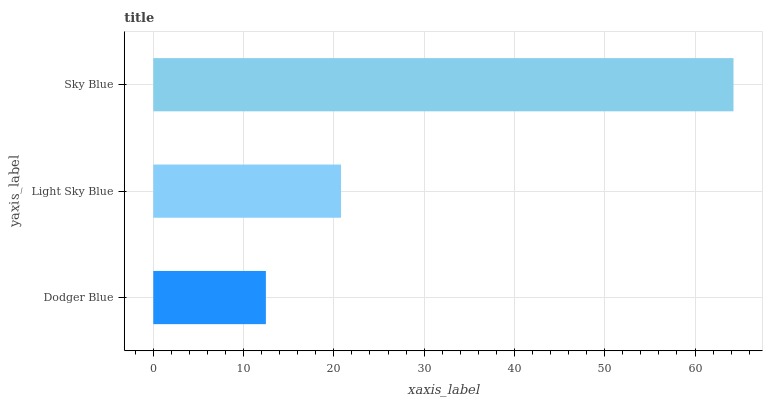Is Dodger Blue the minimum?
Answer yes or no. Yes. Is Sky Blue the maximum?
Answer yes or no. Yes. Is Light Sky Blue the minimum?
Answer yes or no. No. Is Light Sky Blue the maximum?
Answer yes or no. No. Is Light Sky Blue greater than Dodger Blue?
Answer yes or no. Yes. Is Dodger Blue less than Light Sky Blue?
Answer yes or no. Yes. Is Dodger Blue greater than Light Sky Blue?
Answer yes or no. No. Is Light Sky Blue less than Dodger Blue?
Answer yes or no. No. Is Light Sky Blue the high median?
Answer yes or no. Yes. Is Light Sky Blue the low median?
Answer yes or no. Yes. Is Dodger Blue the high median?
Answer yes or no. No. Is Dodger Blue the low median?
Answer yes or no. No. 